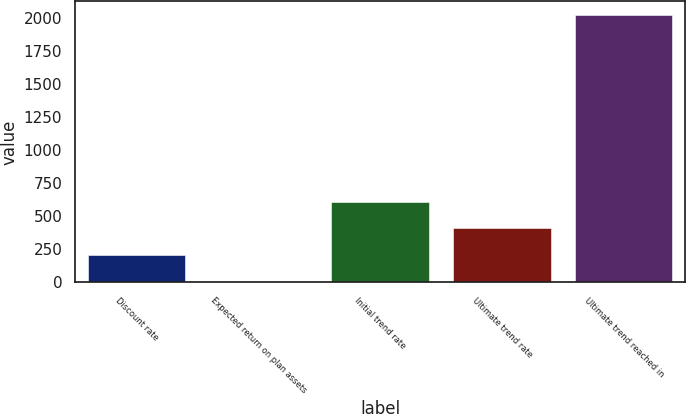Convert chart to OTSL. <chart><loc_0><loc_0><loc_500><loc_500><bar_chart><fcel>Discount rate<fcel>Expected return on plan assets<fcel>Initial trend rate<fcel>Ultimate trend rate<fcel>Ultimate trend reached in<nl><fcel>206.1<fcel>4.45<fcel>609.4<fcel>407.75<fcel>2021<nl></chart> 